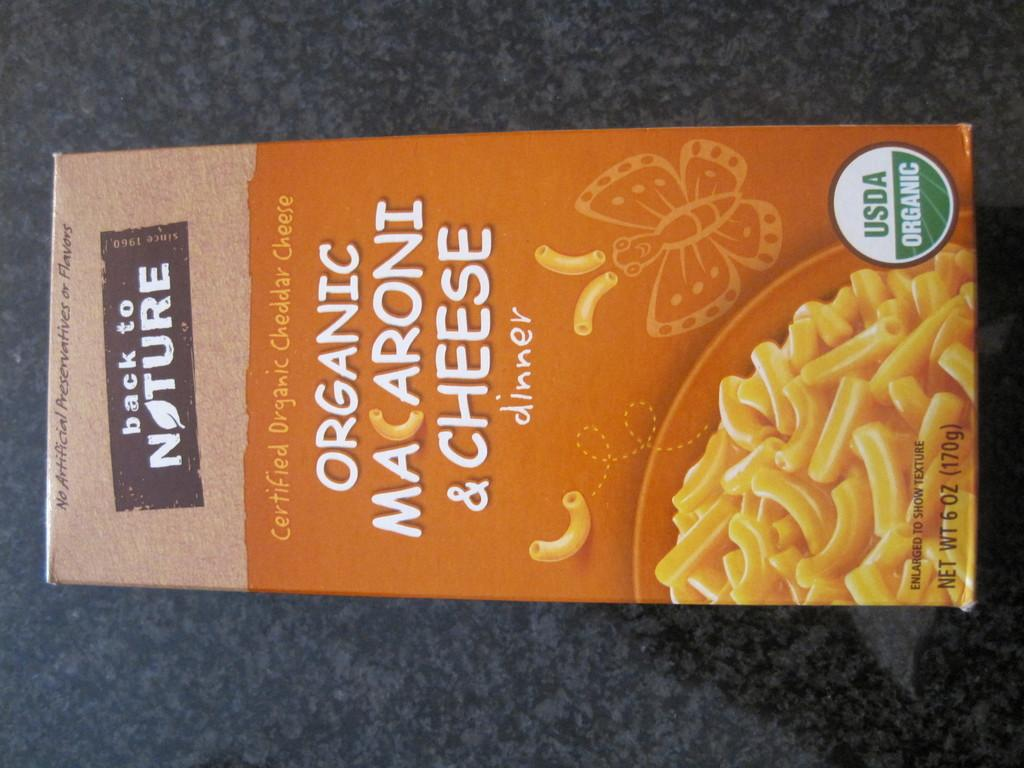<image>
Present a compact description of the photo's key features. A box of Back to Nature Organic Mac and Cheese is lying down on a table. 